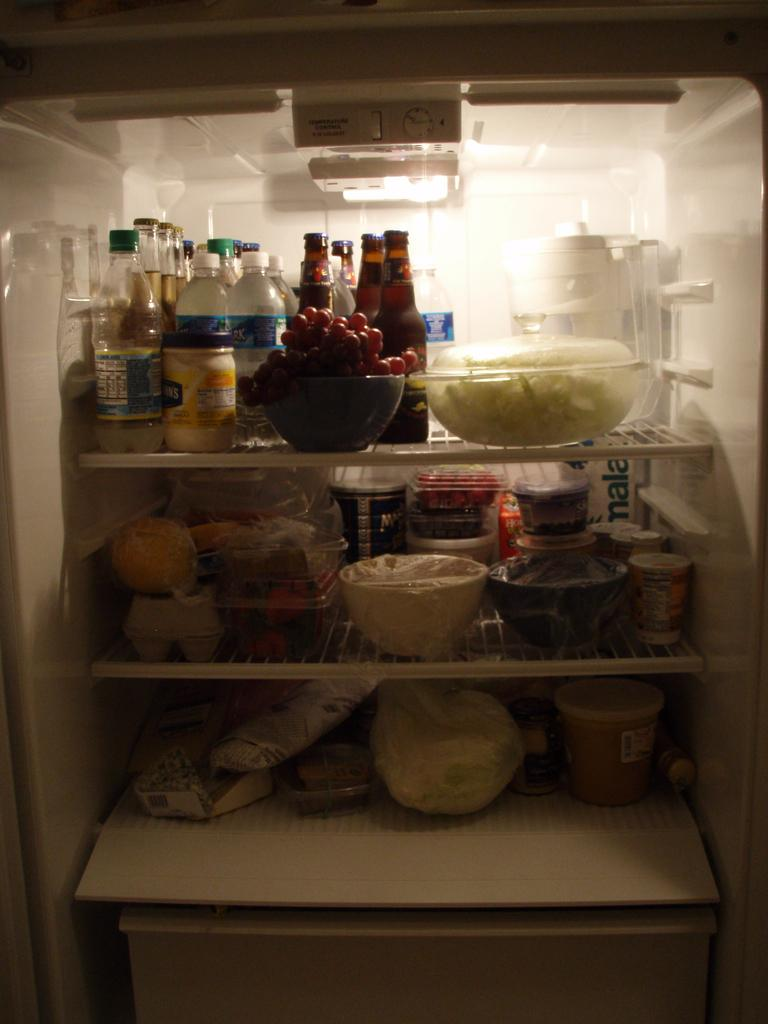<image>
Write a terse but informative summary of the picture. Fridge full of food including a container in the back that says "NALA". 